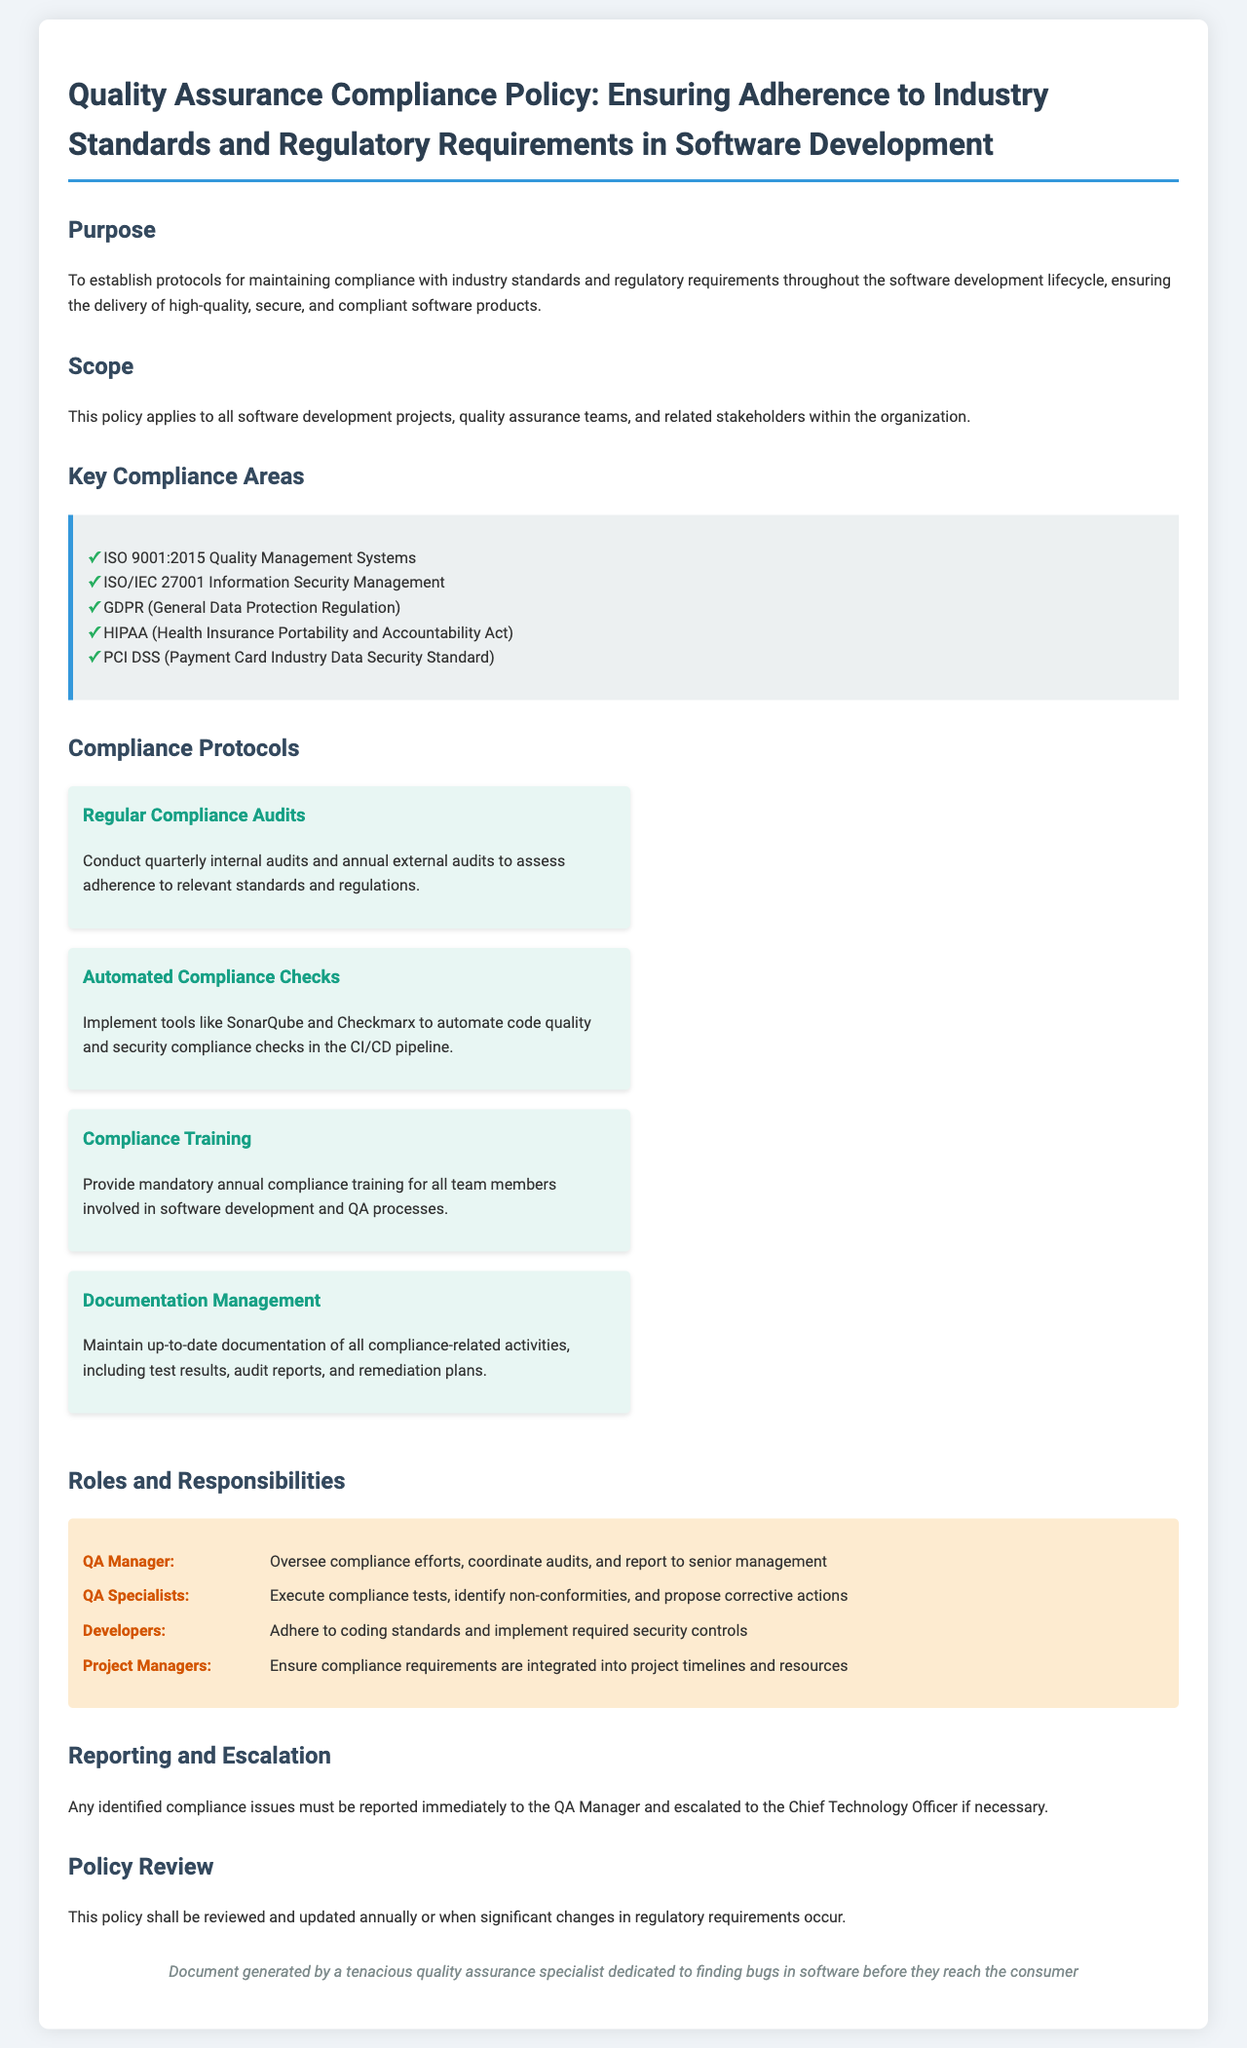What is the purpose of the policy? The purpose is to establish protocols for maintaining compliance with industry standards and regulatory requirements throughout the software development lifecycle.
Answer: Establish protocols for maintaining compliance Who does the policy apply to? The scope of the policy indicates it applies to all software development projects, quality assurance teams, and related stakeholders within the organization.
Answer: All software development projects and QA teams What is the first key compliance area listed? The first key compliance area mentioned in the document is ISO 9001:2015 Quality Management Systems.
Answer: ISO 9001:2015 Quality Management Systems How often should compliance audits be conducted? The document specifies that internal audits are to be conducted quarterly, and external audits annually.
Answer: Quarterly internal and annual external audits What role is responsible for overseeing compliance efforts? The QA Manager is responsible for overseeing compliance efforts according to the roles and responsibilities section.
Answer: QA Manager What type of training is mandatory for team members? The document states that mandatory annual compliance training is required for all team members involved in software development and QA processes.
Answer: Mandatory annual compliance training What happens if compliance issues are identified? Identified compliance issues must be reported immediately to the QA Manager and escalated if necessary.
Answer: Report to the QA Manager and escalate if necessary When will this policy be reviewed? The policy will be reviewed and updated annually or when significant changes in regulatory requirements occur.
Answer: Annually or with significant changes 